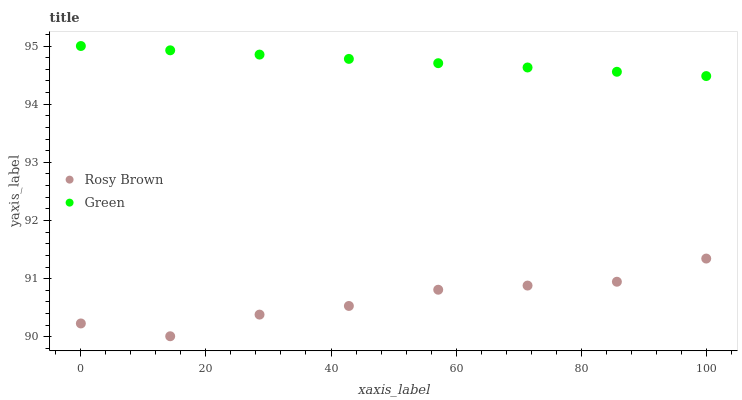Does Rosy Brown have the minimum area under the curve?
Answer yes or no. Yes. Does Green have the maximum area under the curve?
Answer yes or no. Yes. Does Green have the minimum area under the curve?
Answer yes or no. No. Is Green the smoothest?
Answer yes or no. Yes. Is Rosy Brown the roughest?
Answer yes or no. Yes. Is Green the roughest?
Answer yes or no. No. Does Rosy Brown have the lowest value?
Answer yes or no. Yes. Does Green have the lowest value?
Answer yes or no. No. Does Green have the highest value?
Answer yes or no. Yes. Is Rosy Brown less than Green?
Answer yes or no. Yes. Is Green greater than Rosy Brown?
Answer yes or no. Yes. Does Rosy Brown intersect Green?
Answer yes or no. No. 